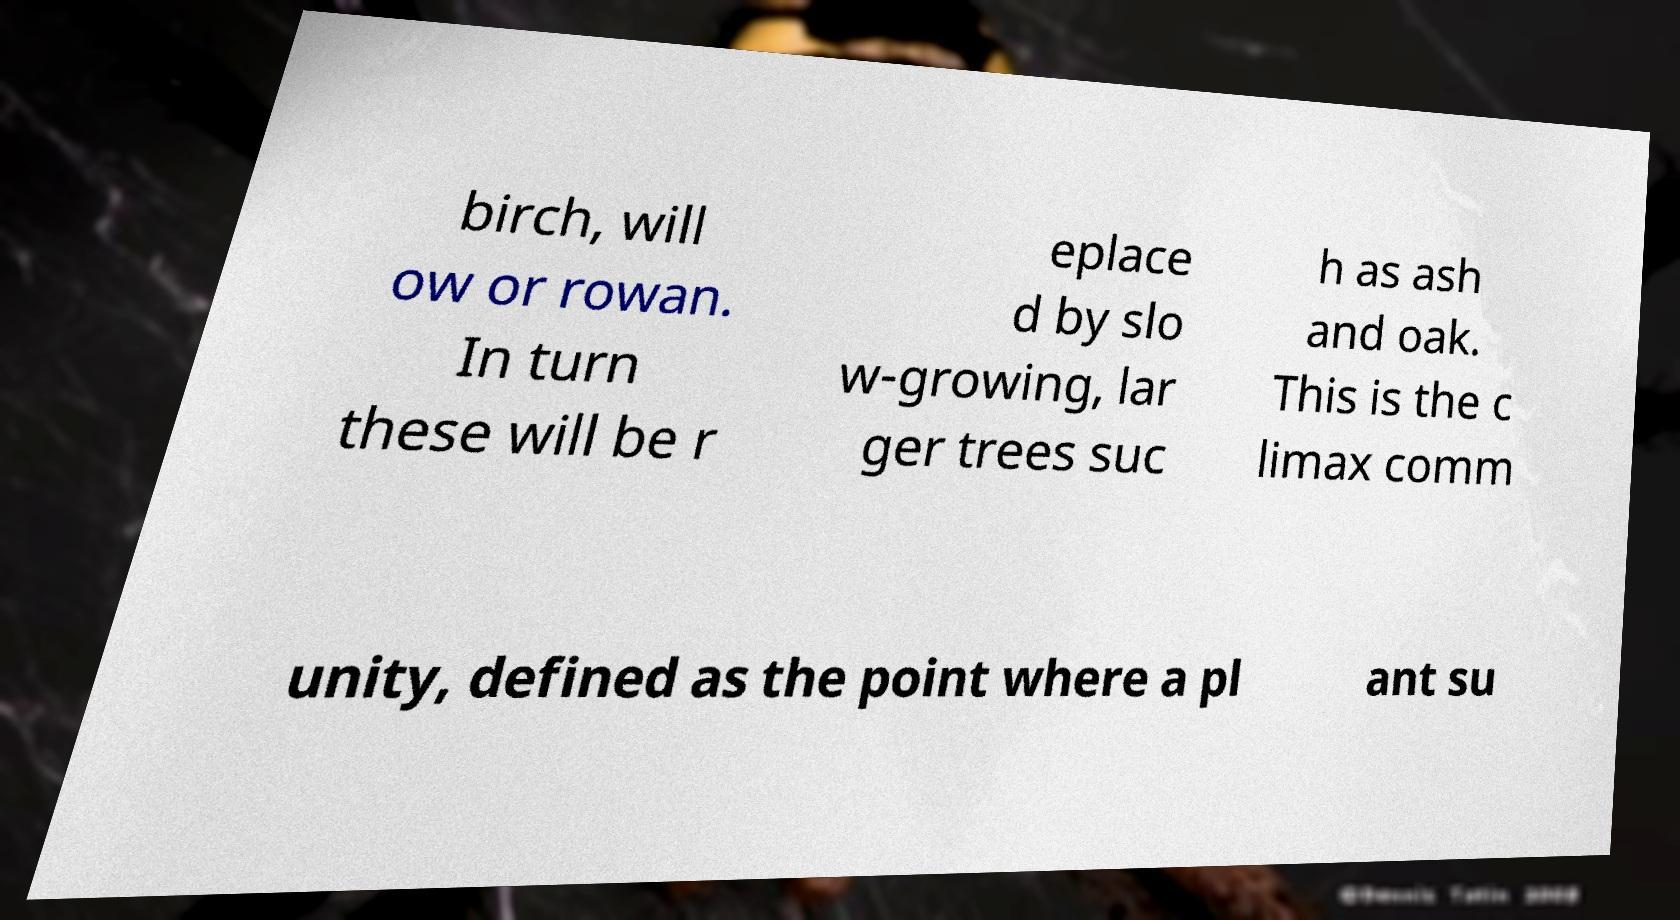Can you read and provide the text displayed in the image?This photo seems to have some interesting text. Can you extract and type it out for me? birch, will ow or rowan. In turn these will be r eplace d by slo w-growing, lar ger trees suc h as ash and oak. This is the c limax comm unity, defined as the point where a pl ant su 